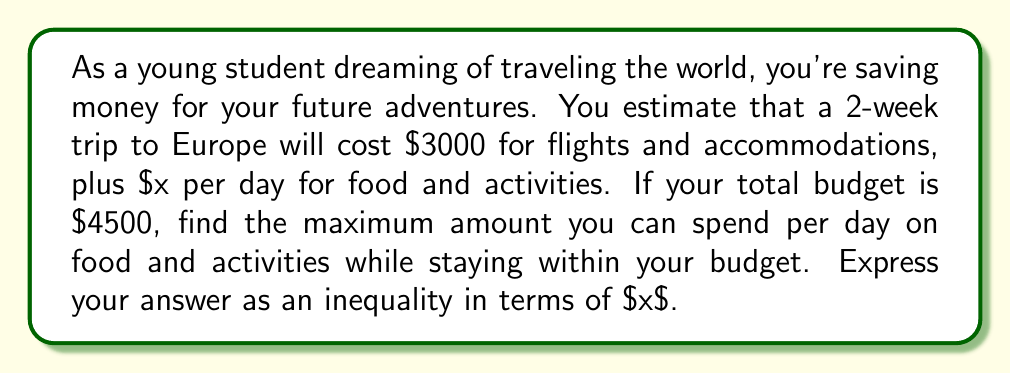Show me your answer to this math problem. Let's approach this step-by-step:

1) First, let's identify the known values:
   - Total budget: $4500
   - Cost of flights and accommodations: $3000
   - Number of days: 14 (2 weeks)
   - Daily spending on food and activities: $x

2) We can set up an inequality where the total expenses should be less than or equal to the budget:

   $$ 3000 + 14x \leq 4500 $$

3) To solve for $x$, let's first subtract 3000 from both sides:

   $$ 14x \leq 1500 $$

4) Now, divide both sides by 14:

   $$ x \leq \frac{1500}{14} $$

5) Simplify the fraction:

   $$ x \leq 107.14285... $$

6) Since we're dealing with currency, we should round down to the nearest cent:

   $$ x \leq 107.14 $$

This inequality represents the maximum amount that can be spent per day on food and activities while staying within the budget.
Answer: $x \leq 107.14$ 